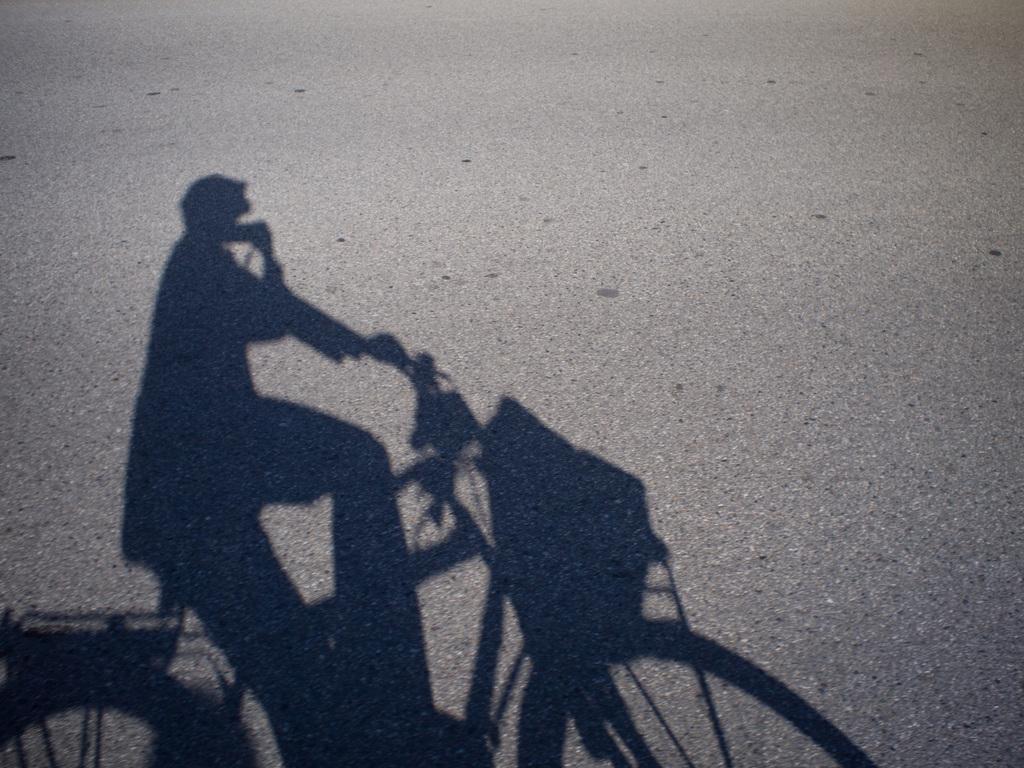Could you give a brief overview of what you see in this image? In this image we can see a shadow of a person riding a bicycle. 